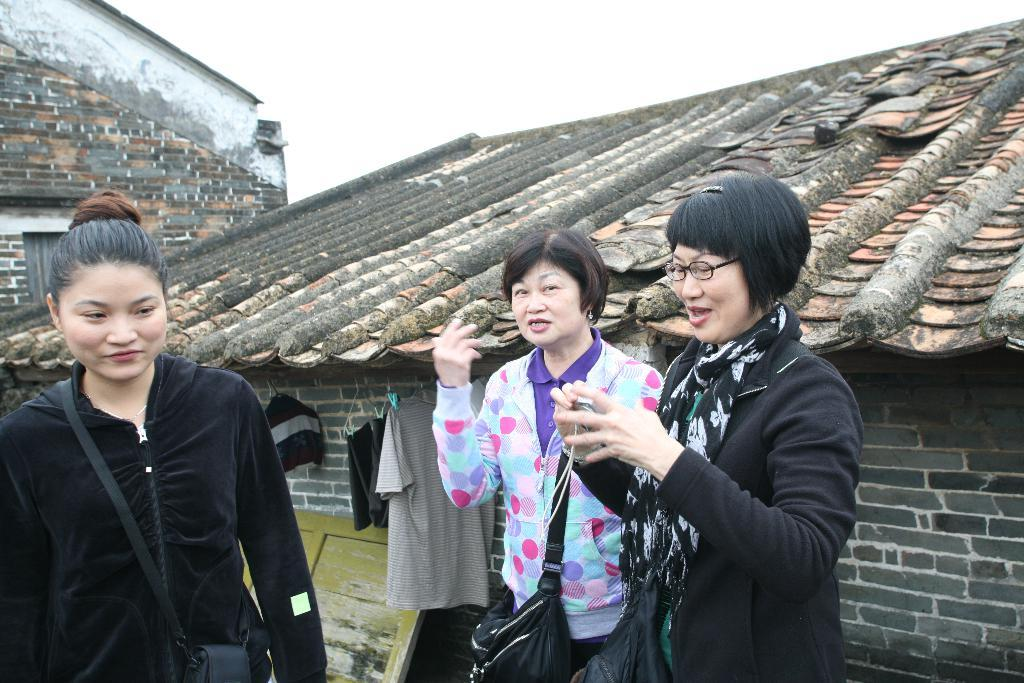How many women are present in the image? There are three women in the image. What is the facial expression of the women? Two of the women are smiling. Can you describe the appearance of one of the women? One of the women is wearing spectacles. What can be seen in the background of the image? There are houses and the sky visible in the background of the image. Are there any birds flying in the cave in the image? There is no cave present in the image, and therefore no birds can be seen flying in it. 